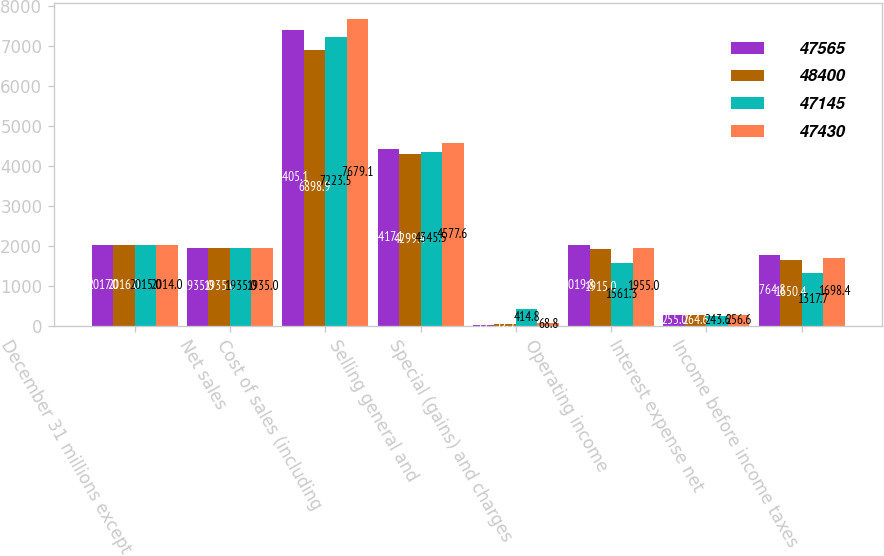<chart> <loc_0><loc_0><loc_500><loc_500><stacked_bar_chart><ecel><fcel>December 31 millions except<fcel>Net sales<fcel>Cost of sales (including<fcel>Selling general and<fcel>Special (gains) and charges<fcel>Operating income<fcel>Interest expense net<fcel>Income before income taxes<nl><fcel>47565<fcel>2017<fcel>1935<fcel>7405.1<fcel>4417.1<fcel>3.7<fcel>2019.8<fcel>255<fcel>1764.8<nl><fcel>48400<fcel>2016<fcel>1935<fcel>6898.9<fcel>4299.4<fcel>39.5<fcel>1915<fcel>264.6<fcel>1650.4<nl><fcel>47145<fcel>2015<fcel>1935<fcel>7223.5<fcel>4345.5<fcel>414.8<fcel>1561.3<fcel>243.6<fcel>1317.7<nl><fcel>47430<fcel>2014<fcel>1935<fcel>7679.1<fcel>4577.6<fcel>68.8<fcel>1955<fcel>256.6<fcel>1698.4<nl></chart> 